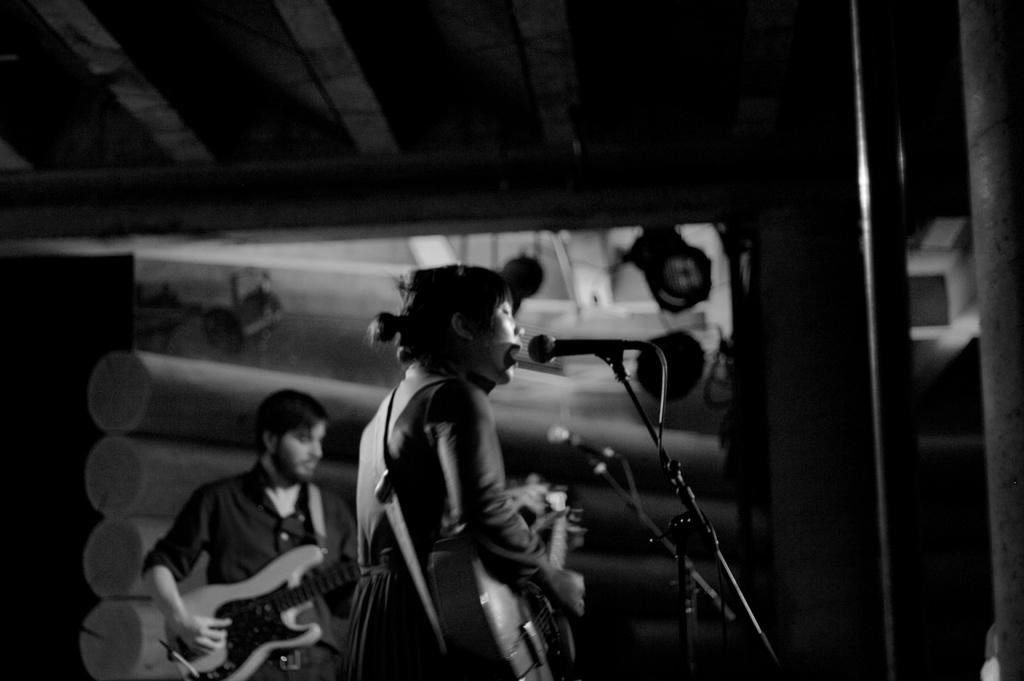What is the color scheme of the image? The image is black and white. How many people are in the image? There are two persons in the image. What are the two persons doing in the image? The two persons are playing guitar. What object in the image is typically used for amplifying sound? There is an object that looks like a microphone (mike) in the image. What type of snow can be seen falling in the image? There is no snow present in the image; it is a black and white image of two persons playing guitar with a microphone-like object. What nation is represented by the flag in the image? There is no flag present in the image. 